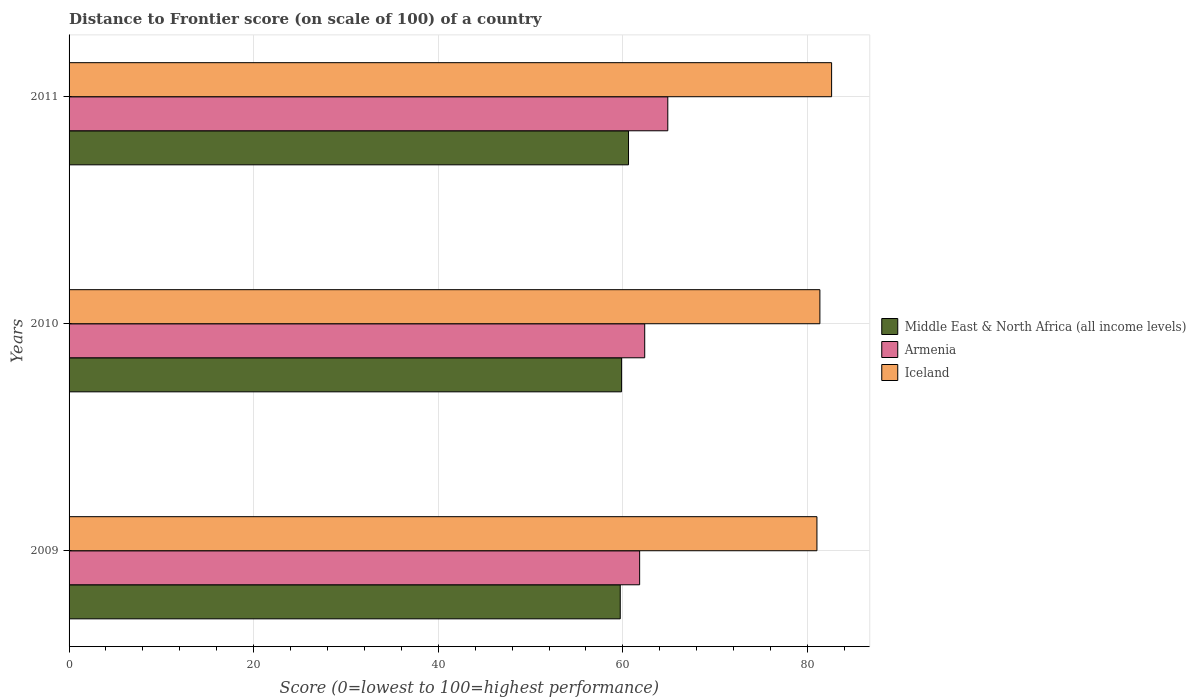How many groups of bars are there?
Make the answer very short. 3. How many bars are there on the 2nd tick from the top?
Offer a terse response. 3. What is the label of the 2nd group of bars from the top?
Make the answer very short. 2010. In how many cases, is the number of bars for a given year not equal to the number of legend labels?
Offer a very short reply. 0. What is the distance to frontier score of in Armenia in 2010?
Offer a very short reply. 62.37. Across all years, what is the maximum distance to frontier score of in Armenia?
Make the answer very short. 64.87. Across all years, what is the minimum distance to frontier score of in Armenia?
Give a very brief answer. 61.82. In which year was the distance to frontier score of in Middle East & North Africa (all income levels) maximum?
Provide a short and direct response. 2011. In which year was the distance to frontier score of in Middle East & North Africa (all income levels) minimum?
Make the answer very short. 2009. What is the total distance to frontier score of in Middle East & North Africa (all income levels) in the graph?
Give a very brief answer. 180.2. What is the difference between the distance to frontier score of in Armenia in 2009 and that in 2010?
Ensure brevity in your answer.  -0.55. What is the difference between the distance to frontier score of in Armenia in 2010 and the distance to frontier score of in Middle East & North Africa (all income levels) in 2011?
Your response must be concise. 1.76. What is the average distance to frontier score of in Armenia per year?
Make the answer very short. 63.02. In the year 2009, what is the difference between the distance to frontier score of in Iceland and distance to frontier score of in Middle East & North Africa (all income levels)?
Your answer should be compact. 21.31. In how many years, is the distance to frontier score of in Iceland greater than 24 ?
Offer a very short reply. 3. What is the ratio of the distance to frontier score of in Armenia in 2009 to that in 2011?
Keep it short and to the point. 0.95. What is the difference between the highest and the second highest distance to frontier score of in Armenia?
Offer a terse response. 2.5. What is the difference between the highest and the lowest distance to frontier score of in Middle East & North Africa (all income levels)?
Your answer should be very brief. 0.9. In how many years, is the distance to frontier score of in Iceland greater than the average distance to frontier score of in Iceland taken over all years?
Make the answer very short. 1. Is the sum of the distance to frontier score of in Iceland in 2009 and 2011 greater than the maximum distance to frontier score of in Middle East & North Africa (all income levels) across all years?
Provide a succinct answer. Yes. Is it the case that in every year, the sum of the distance to frontier score of in Iceland and distance to frontier score of in Armenia is greater than the distance to frontier score of in Middle East & North Africa (all income levels)?
Offer a very short reply. Yes. How many bars are there?
Provide a succinct answer. 9. Are all the bars in the graph horizontal?
Make the answer very short. Yes. How many years are there in the graph?
Ensure brevity in your answer.  3. What is the difference between two consecutive major ticks on the X-axis?
Provide a short and direct response. 20. Does the graph contain any zero values?
Your answer should be compact. No. Where does the legend appear in the graph?
Provide a succinct answer. Center right. How are the legend labels stacked?
Provide a short and direct response. Vertical. What is the title of the graph?
Ensure brevity in your answer.  Distance to Frontier score (on scale of 100) of a country. Does "Nicaragua" appear as one of the legend labels in the graph?
Your response must be concise. No. What is the label or title of the X-axis?
Keep it short and to the point. Score (0=lowest to 100=highest performance). What is the label or title of the Y-axis?
Your response must be concise. Years. What is the Score (0=lowest to 100=highest performance) in Middle East & North Africa (all income levels) in 2009?
Make the answer very short. 59.72. What is the Score (0=lowest to 100=highest performance) of Armenia in 2009?
Your answer should be very brief. 61.82. What is the Score (0=lowest to 100=highest performance) of Iceland in 2009?
Your answer should be compact. 81.03. What is the Score (0=lowest to 100=highest performance) of Middle East & North Africa (all income levels) in 2010?
Give a very brief answer. 59.86. What is the Score (0=lowest to 100=highest performance) of Armenia in 2010?
Your answer should be very brief. 62.37. What is the Score (0=lowest to 100=highest performance) in Iceland in 2010?
Offer a very short reply. 81.35. What is the Score (0=lowest to 100=highest performance) of Middle East & North Africa (all income levels) in 2011?
Offer a very short reply. 60.61. What is the Score (0=lowest to 100=highest performance) of Armenia in 2011?
Your answer should be compact. 64.87. What is the Score (0=lowest to 100=highest performance) in Iceland in 2011?
Give a very brief answer. 82.62. Across all years, what is the maximum Score (0=lowest to 100=highest performance) in Middle East & North Africa (all income levels)?
Ensure brevity in your answer.  60.61. Across all years, what is the maximum Score (0=lowest to 100=highest performance) of Armenia?
Your answer should be very brief. 64.87. Across all years, what is the maximum Score (0=lowest to 100=highest performance) in Iceland?
Keep it short and to the point. 82.62. Across all years, what is the minimum Score (0=lowest to 100=highest performance) in Middle East & North Africa (all income levels)?
Ensure brevity in your answer.  59.72. Across all years, what is the minimum Score (0=lowest to 100=highest performance) in Armenia?
Make the answer very short. 61.82. Across all years, what is the minimum Score (0=lowest to 100=highest performance) in Iceland?
Your answer should be compact. 81.03. What is the total Score (0=lowest to 100=highest performance) of Middle East & North Africa (all income levels) in the graph?
Ensure brevity in your answer.  180.2. What is the total Score (0=lowest to 100=highest performance) in Armenia in the graph?
Your response must be concise. 189.06. What is the total Score (0=lowest to 100=highest performance) of Iceland in the graph?
Make the answer very short. 245. What is the difference between the Score (0=lowest to 100=highest performance) of Middle East & North Africa (all income levels) in 2009 and that in 2010?
Your answer should be compact. -0.14. What is the difference between the Score (0=lowest to 100=highest performance) in Armenia in 2009 and that in 2010?
Your answer should be compact. -0.55. What is the difference between the Score (0=lowest to 100=highest performance) of Iceland in 2009 and that in 2010?
Offer a terse response. -0.32. What is the difference between the Score (0=lowest to 100=highest performance) of Middle East & North Africa (all income levels) in 2009 and that in 2011?
Offer a terse response. -0.9. What is the difference between the Score (0=lowest to 100=highest performance) of Armenia in 2009 and that in 2011?
Your answer should be compact. -3.05. What is the difference between the Score (0=lowest to 100=highest performance) in Iceland in 2009 and that in 2011?
Offer a terse response. -1.59. What is the difference between the Score (0=lowest to 100=highest performance) of Middle East & North Africa (all income levels) in 2010 and that in 2011?
Provide a short and direct response. -0.75. What is the difference between the Score (0=lowest to 100=highest performance) in Armenia in 2010 and that in 2011?
Keep it short and to the point. -2.5. What is the difference between the Score (0=lowest to 100=highest performance) in Iceland in 2010 and that in 2011?
Your answer should be very brief. -1.27. What is the difference between the Score (0=lowest to 100=highest performance) in Middle East & North Africa (all income levels) in 2009 and the Score (0=lowest to 100=highest performance) in Armenia in 2010?
Keep it short and to the point. -2.65. What is the difference between the Score (0=lowest to 100=highest performance) of Middle East & North Africa (all income levels) in 2009 and the Score (0=lowest to 100=highest performance) of Iceland in 2010?
Make the answer very short. -21.63. What is the difference between the Score (0=lowest to 100=highest performance) of Armenia in 2009 and the Score (0=lowest to 100=highest performance) of Iceland in 2010?
Ensure brevity in your answer.  -19.53. What is the difference between the Score (0=lowest to 100=highest performance) of Middle East & North Africa (all income levels) in 2009 and the Score (0=lowest to 100=highest performance) of Armenia in 2011?
Your response must be concise. -5.15. What is the difference between the Score (0=lowest to 100=highest performance) of Middle East & North Africa (all income levels) in 2009 and the Score (0=lowest to 100=highest performance) of Iceland in 2011?
Offer a terse response. -22.9. What is the difference between the Score (0=lowest to 100=highest performance) in Armenia in 2009 and the Score (0=lowest to 100=highest performance) in Iceland in 2011?
Offer a very short reply. -20.8. What is the difference between the Score (0=lowest to 100=highest performance) in Middle East & North Africa (all income levels) in 2010 and the Score (0=lowest to 100=highest performance) in Armenia in 2011?
Your answer should be compact. -5.01. What is the difference between the Score (0=lowest to 100=highest performance) of Middle East & North Africa (all income levels) in 2010 and the Score (0=lowest to 100=highest performance) of Iceland in 2011?
Make the answer very short. -22.76. What is the difference between the Score (0=lowest to 100=highest performance) of Armenia in 2010 and the Score (0=lowest to 100=highest performance) of Iceland in 2011?
Provide a short and direct response. -20.25. What is the average Score (0=lowest to 100=highest performance) of Middle East & North Africa (all income levels) per year?
Make the answer very short. 60.07. What is the average Score (0=lowest to 100=highest performance) in Armenia per year?
Give a very brief answer. 63.02. What is the average Score (0=lowest to 100=highest performance) in Iceland per year?
Provide a succinct answer. 81.67. In the year 2009, what is the difference between the Score (0=lowest to 100=highest performance) in Middle East & North Africa (all income levels) and Score (0=lowest to 100=highest performance) in Armenia?
Keep it short and to the point. -2.1. In the year 2009, what is the difference between the Score (0=lowest to 100=highest performance) in Middle East & North Africa (all income levels) and Score (0=lowest to 100=highest performance) in Iceland?
Offer a very short reply. -21.31. In the year 2009, what is the difference between the Score (0=lowest to 100=highest performance) of Armenia and Score (0=lowest to 100=highest performance) of Iceland?
Provide a short and direct response. -19.21. In the year 2010, what is the difference between the Score (0=lowest to 100=highest performance) in Middle East & North Africa (all income levels) and Score (0=lowest to 100=highest performance) in Armenia?
Ensure brevity in your answer.  -2.51. In the year 2010, what is the difference between the Score (0=lowest to 100=highest performance) of Middle East & North Africa (all income levels) and Score (0=lowest to 100=highest performance) of Iceland?
Ensure brevity in your answer.  -21.49. In the year 2010, what is the difference between the Score (0=lowest to 100=highest performance) of Armenia and Score (0=lowest to 100=highest performance) of Iceland?
Offer a very short reply. -18.98. In the year 2011, what is the difference between the Score (0=lowest to 100=highest performance) of Middle East & North Africa (all income levels) and Score (0=lowest to 100=highest performance) of Armenia?
Offer a terse response. -4.26. In the year 2011, what is the difference between the Score (0=lowest to 100=highest performance) of Middle East & North Africa (all income levels) and Score (0=lowest to 100=highest performance) of Iceland?
Ensure brevity in your answer.  -22.01. In the year 2011, what is the difference between the Score (0=lowest to 100=highest performance) in Armenia and Score (0=lowest to 100=highest performance) in Iceland?
Your answer should be compact. -17.75. What is the ratio of the Score (0=lowest to 100=highest performance) in Armenia in 2009 to that in 2010?
Provide a short and direct response. 0.99. What is the ratio of the Score (0=lowest to 100=highest performance) in Middle East & North Africa (all income levels) in 2009 to that in 2011?
Give a very brief answer. 0.99. What is the ratio of the Score (0=lowest to 100=highest performance) of Armenia in 2009 to that in 2011?
Ensure brevity in your answer.  0.95. What is the ratio of the Score (0=lowest to 100=highest performance) in Iceland in 2009 to that in 2011?
Provide a short and direct response. 0.98. What is the ratio of the Score (0=lowest to 100=highest performance) in Middle East & North Africa (all income levels) in 2010 to that in 2011?
Keep it short and to the point. 0.99. What is the ratio of the Score (0=lowest to 100=highest performance) of Armenia in 2010 to that in 2011?
Keep it short and to the point. 0.96. What is the ratio of the Score (0=lowest to 100=highest performance) in Iceland in 2010 to that in 2011?
Provide a short and direct response. 0.98. What is the difference between the highest and the second highest Score (0=lowest to 100=highest performance) of Middle East & North Africa (all income levels)?
Your answer should be compact. 0.75. What is the difference between the highest and the second highest Score (0=lowest to 100=highest performance) in Armenia?
Provide a succinct answer. 2.5. What is the difference between the highest and the second highest Score (0=lowest to 100=highest performance) in Iceland?
Give a very brief answer. 1.27. What is the difference between the highest and the lowest Score (0=lowest to 100=highest performance) in Middle East & North Africa (all income levels)?
Your answer should be very brief. 0.9. What is the difference between the highest and the lowest Score (0=lowest to 100=highest performance) of Armenia?
Give a very brief answer. 3.05. What is the difference between the highest and the lowest Score (0=lowest to 100=highest performance) of Iceland?
Provide a short and direct response. 1.59. 